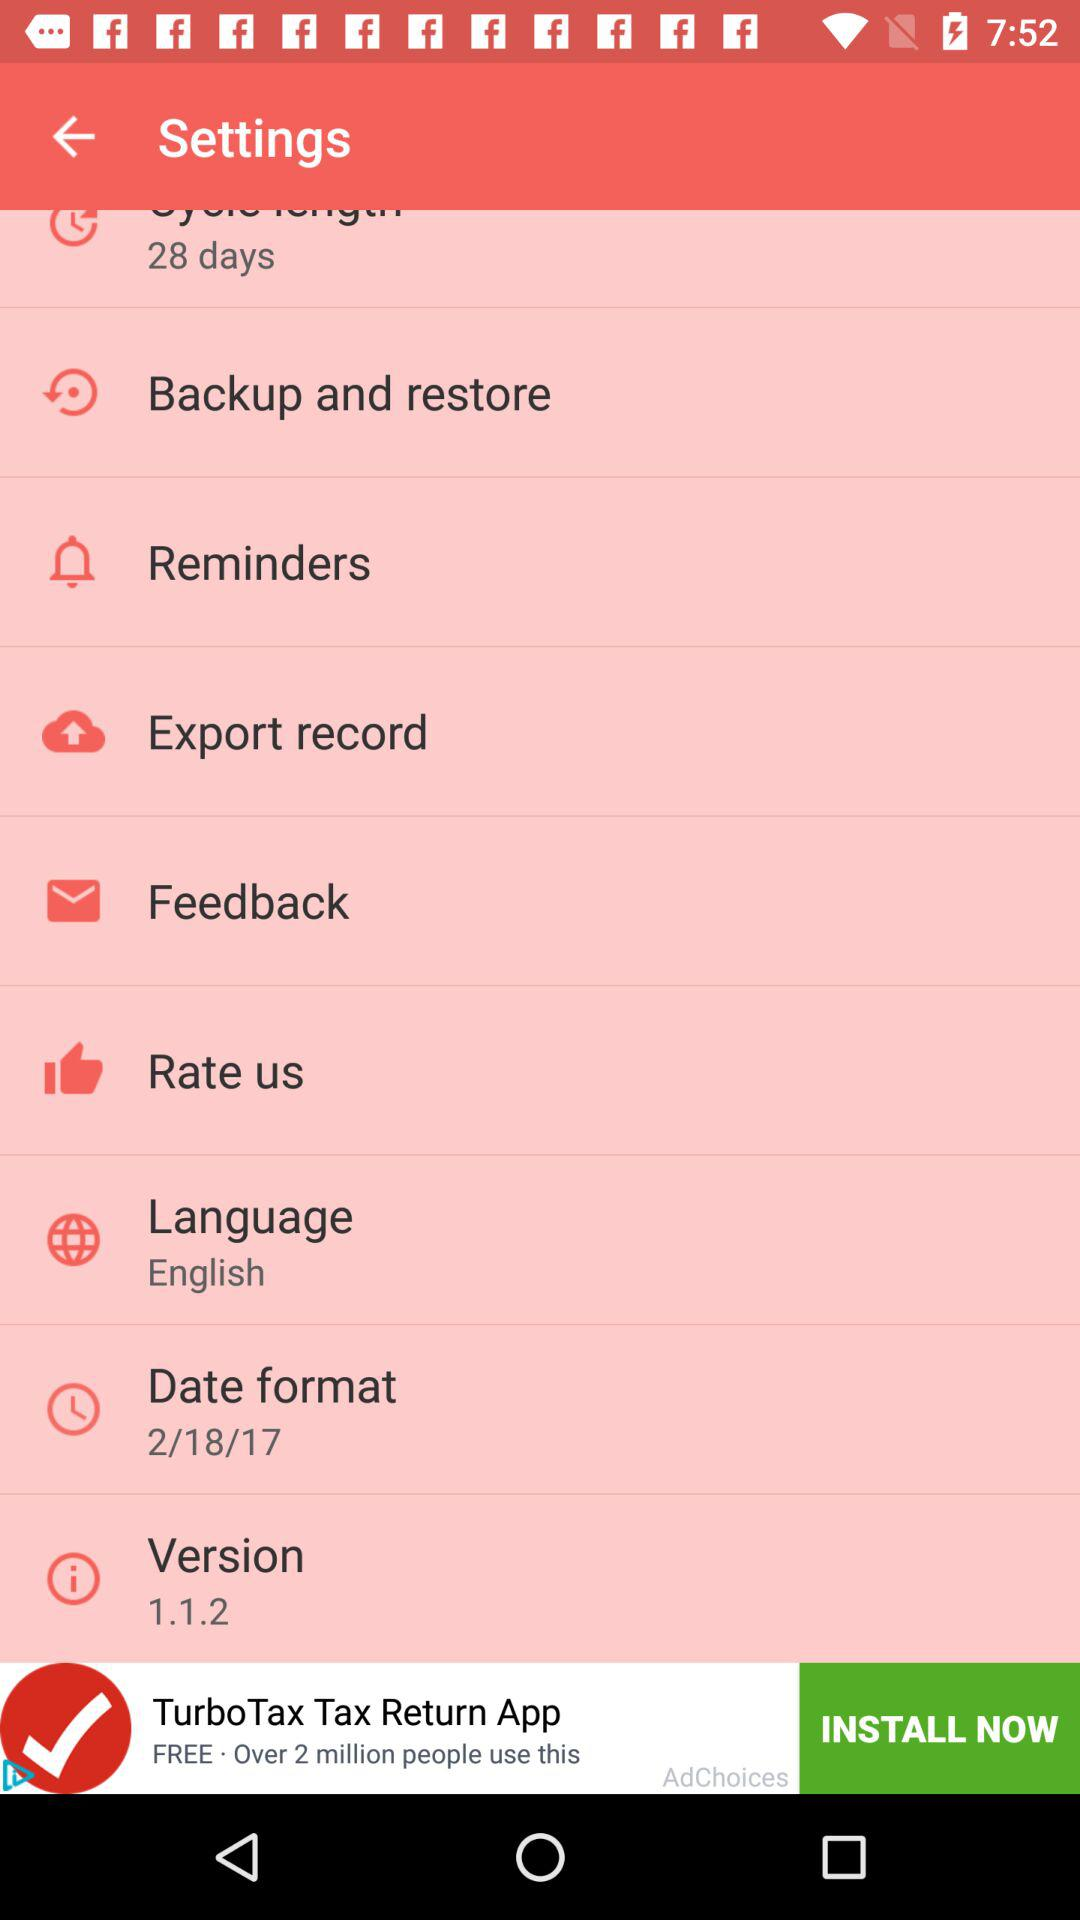What is the selected date format? The selected date format is 2/18/17. 